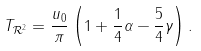<formula> <loc_0><loc_0><loc_500><loc_500>T _ { \mathcal { R } ^ { 2 } } = \frac { u _ { 0 } } { \pi } \left ( 1 + \frac { 1 } { 4 } \alpha - \frac { 5 } { 4 } \gamma \right ) .</formula> 